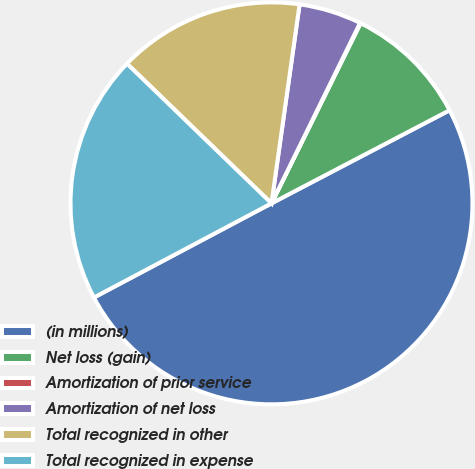Convert chart to OTSL. <chart><loc_0><loc_0><loc_500><loc_500><pie_chart><fcel>(in millions)<fcel>Net loss (gain)<fcel>Amortization of prior service<fcel>Amortization of net loss<fcel>Total recognized in other<fcel>Total recognized in expense<nl><fcel>49.9%<fcel>10.02%<fcel>0.05%<fcel>5.03%<fcel>15.0%<fcel>19.99%<nl></chart> 